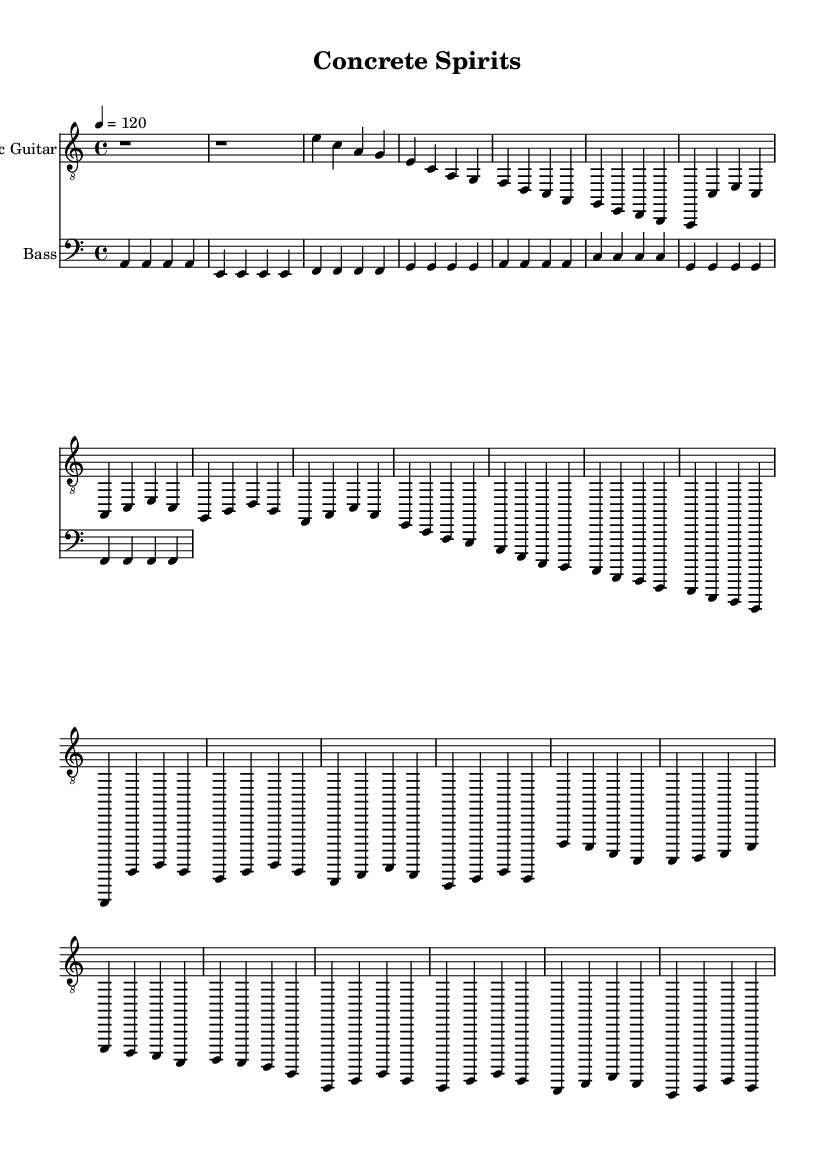What is the key signature of this music? The key signature is A minor, which has no sharps or flats.
Answer: A minor What is the time signature of this music? The time signature shows a 4/4 signature, indicating four beats per measure.
Answer: 4/4 What is the tempo marking of the piece? The tempo marking is shown as quarter note equals 120 beats per minute, indicating a moderate pace.
Answer: 120 How many verses are present in the structure? By examining the sections labeled as 'Verse 1' and 'Verse 2', we see there are two verses in the piece.
Answer: 2 In what section does the bridge appear? The bridge appears after the second chorus, specifically labeled as 'Bridge' in the sheet music.
Answer: After the second chorus What is the primary mood conveyed in the chorus through the chord choices? The chorus features major chords primarily, which typically convey a bright or uplifting mood contrasting with the minor-based verses.
Answer: Bright What unique characteristic identifies this piece as Electric Blues? The use of electric guitar and the typical blues structure with call-and-response patterns, such as the verses leading to choruses, are characteristic.
Answer: Electric guitar 